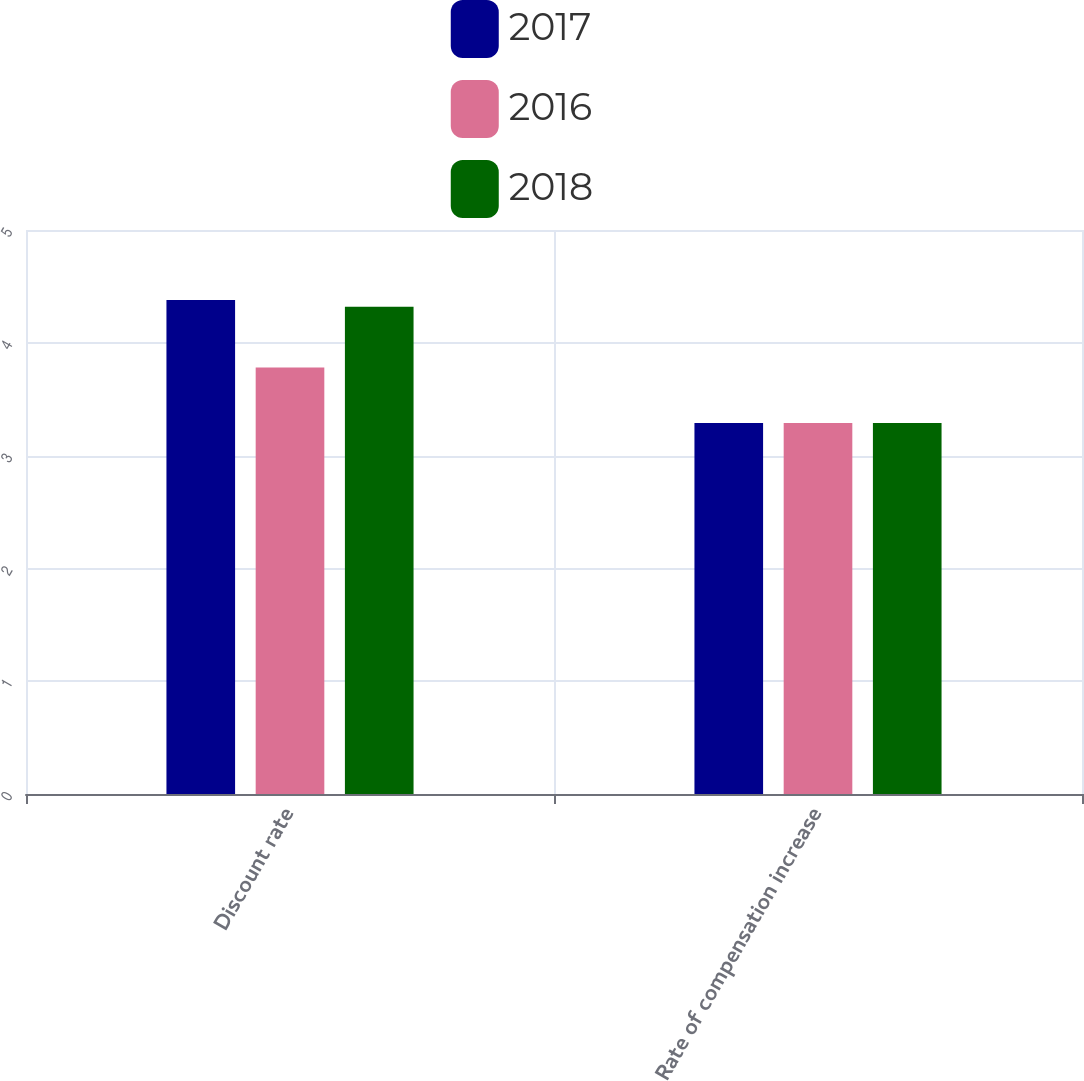<chart> <loc_0><loc_0><loc_500><loc_500><stacked_bar_chart><ecel><fcel>Discount rate<fcel>Rate of compensation increase<nl><fcel>2017<fcel>4.38<fcel>3.29<nl><fcel>2016<fcel>3.78<fcel>3.29<nl><fcel>2018<fcel>4.32<fcel>3.29<nl></chart> 